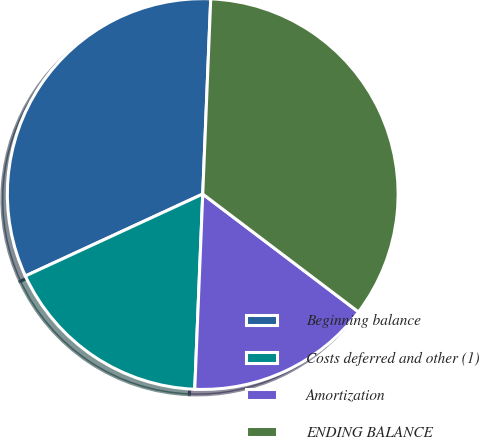<chart> <loc_0><loc_0><loc_500><loc_500><pie_chart><fcel>Beginning balance<fcel>Costs deferred and other (1)<fcel>Amortization<fcel>ENDING BALANCE<nl><fcel>32.54%<fcel>17.46%<fcel>15.34%<fcel>34.66%<nl></chart> 